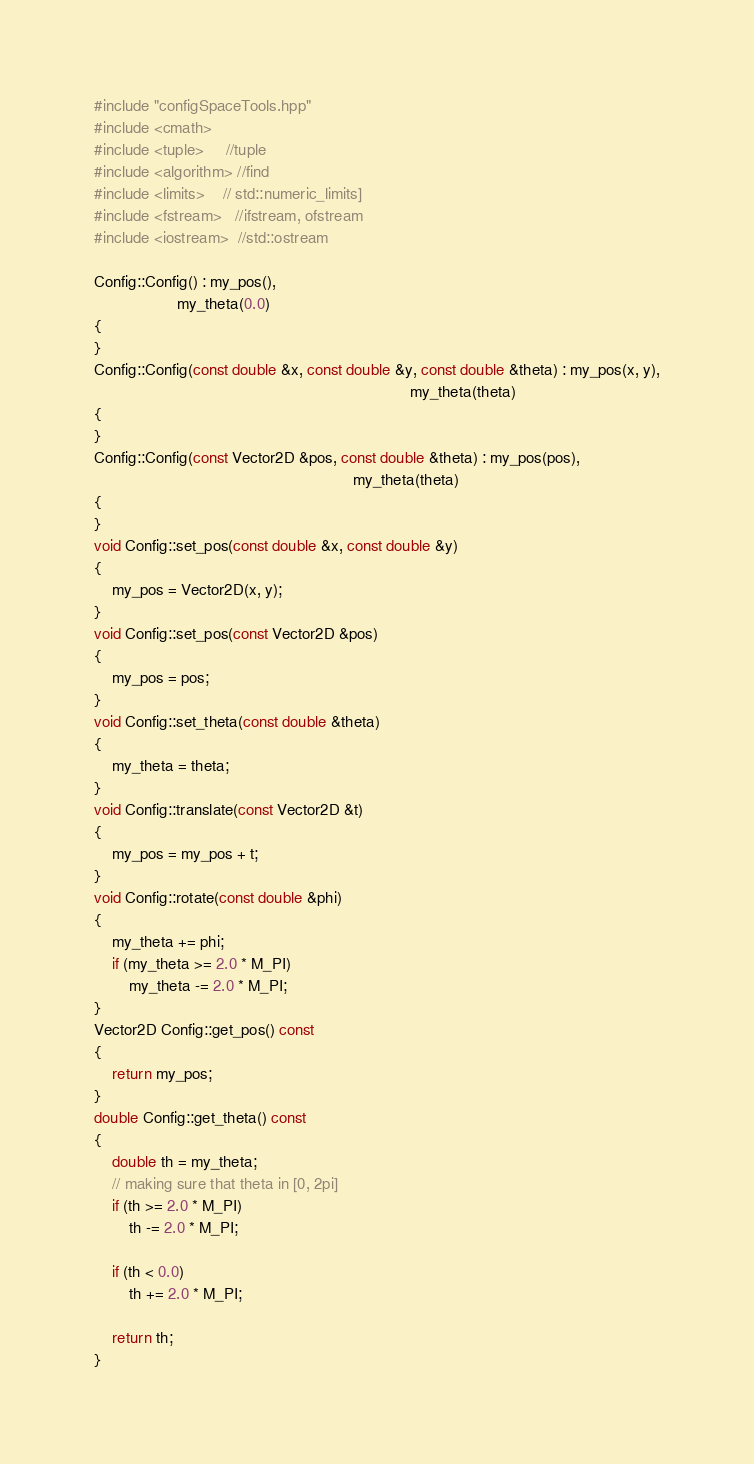<code> <loc_0><loc_0><loc_500><loc_500><_C++_>#include "configSpaceTools.hpp"
#include <cmath>
#include <tuple>     //tuple
#include <algorithm> //find
#include <limits>    // std::numeric_limits]
#include <fstream>   //ifstream, ofstream
#include <iostream>  //std::ostream

Config::Config() : my_pos(),
                   my_theta(0.0)
{
}
Config::Config(const double &x, const double &y, const double &theta) : my_pos(x, y),
                                                                        my_theta(theta)
{
}
Config::Config(const Vector2D &pos, const double &theta) : my_pos(pos),
                                                           my_theta(theta)
{
}
void Config::set_pos(const double &x, const double &y)
{
    my_pos = Vector2D(x, y);
}
void Config::set_pos(const Vector2D &pos)
{
    my_pos = pos;
}
void Config::set_theta(const double &theta)
{
    my_theta = theta;
}
void Config::translate(const Vector2D &t)
{
    my_pos = my_pos + t;
}
void Config::rotate(const double &phi)
{
    my_theta += phi;
    if (my_theta >= 2.0 * M_PI)
        my_theta -= 2.0 * M_PI;
}
Vector2D Config::get_pos() const
{
    return my_pos;
}
double Config::get_theta() const
{
    double th = my_theta;
    // making sure that theta in [0, 2pi]
    if (th >= 2.0 * M_PI)
        th -= 2.0 * M_PI;

    if (th < 0.0)
        th += 2.0 * M_PI;

    return th;
}
</code> 